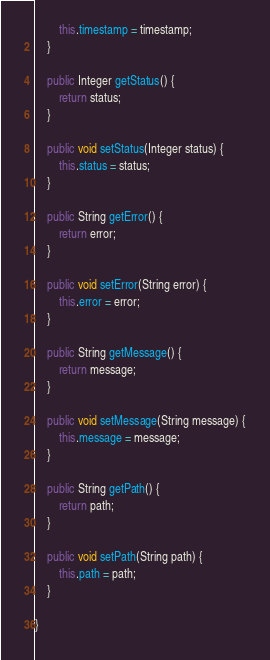<code> <loc_0><loc_0><loc_500><loc_500><_Java_>		this.timestamp = timestamp;
	}

	public Integer getStatus() {
		return status;
	}

	public void setStatus(Integer status) {
		this.status = status;
	}

	public String getError() {
		return error;
	}

	public void setError(String error) {
		this.error = error;
	}

	public String getMessage() {
		return message;
	}

	public void setMessage(String message) {
		this.message = message;
	}

	public String getPath() {
		return path;
	}

	public void setPath(String path) {
		this.path = path;
	}

}
</code> 